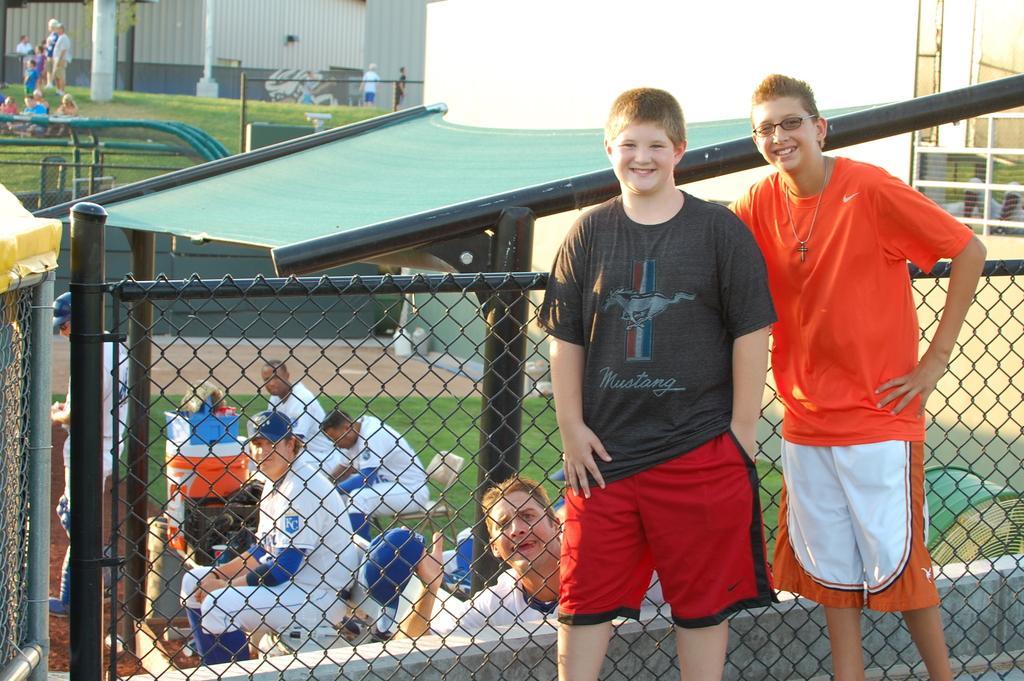In one or two sentences, can you explain what this image depicts? In this image in the foreground there are two boys standing, and in the background there is a net and some persons are sitting and also we could see some baskets, poles, roof and some persons standing, grass, buildings, net and some objects. 